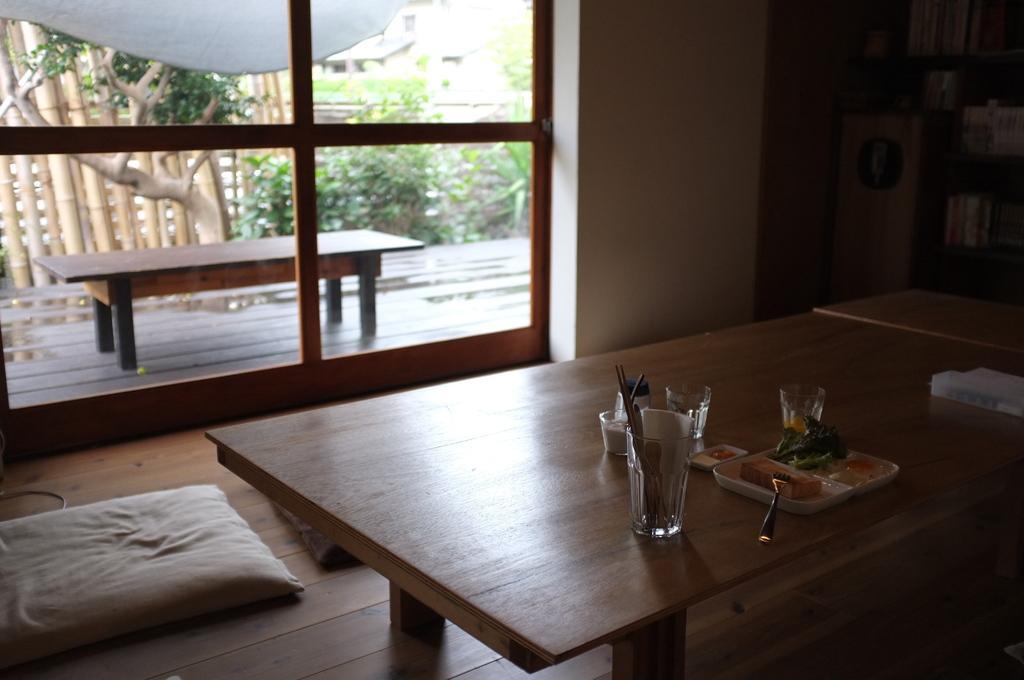Can you describe this image briefly? In this picture we can see inside of the room, in which we can see a table, on the table some glasses, plates, spoons are placed, down we can see pillow on the floor and we can see glass window. 